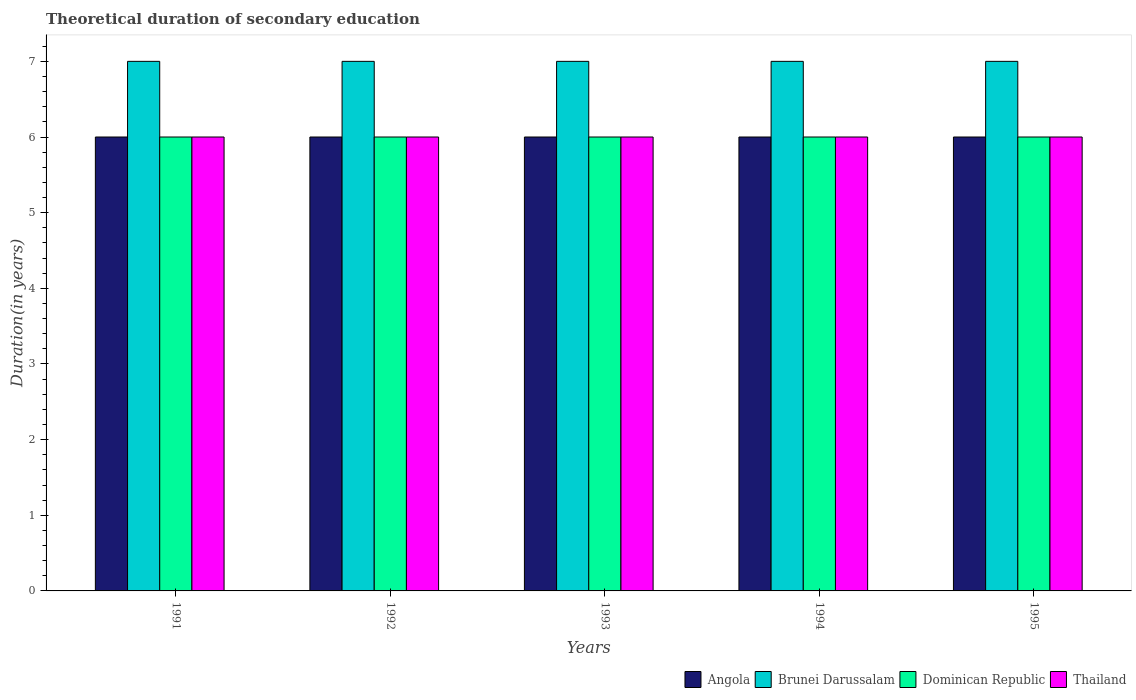How many groups of bars are there?
Provide a succinct answer. 5. Are the number of bars per tick equal to the number of legend labels?
Offer a very short reply. Yes. Are the number of bars on each tick of the X-axis equal?
Keep it short and to the point. Yes. What is the label of the 3rd group of bars from the left?
Give a very brief answer. 1993. In how many cases, is the number of bars for a given year not equal to the number of legend labels?
Your answer should be very brief. 0. What is the total theoretical duration of secondary education in Thailand in 1995?
Your response must be concise. 6. Across all years, what is the minimum total theoretical duration of secondary education in Angola?
Give a very brief answer. 6. In which year was the total theoretical duration of secondary education in Dominican Republic maximum?
Your response must be concise. 1991. What is the total total theoretical duration of secondary education in Angola in the graph?
Your answer should be very brief. 30. What is the difference between the total theoretical duration of secondary education in Brunei Darussalam in 1991 and that in 1994?
Give a very brief answer. 0. What is the difference between the total theoretical duration of secondary education in Brunei Darussalam in 1993 and the total theoretical duration of secondary education in Angola in 1991?
Keep it short and to the point. 1. What is the average total theoretical duration of secondary education in Brunei Darussalam per year?
Provide a short and direct response. 7. In the year 1991, what is the difference between the total theoretical duration of secondary education in Angola and total theoretical duration of secondary education in Brunei Darussalam?
Offer a terse response. -1. In how many years, is the total theoretical duration of secondary education in Angola greater than 5 years?
Your answer should be very brief. 5. Is the difference between the total theoretical duration of secondary education in Angola in 1991 and 1995 greater than the difference between the total theoretical duration of secondary education in Brunei Darussalam in 1991 and 1995?
Offer a very short reply. No. What is the difference between the highest and the second highest total theoretical duration of secondary education in Angola?
Provide a short and direct response. 0. What is the difference between the highest and the lowest total theoretical duration of secondary education in Thailand?
Your answer should be compact. 0. In how many years, is the total theoretical duration of secondary education in Brunei Darussalam greater than the average total theoretical duration of secondary education in Brunei Darussalam taken over all years?
Your answer should be compact. 0. Is it the case that in every year, the sum of the total theoretical duration of secondary education in Thailand and total theoretical duration of secondary education in Dominican Republic is greater than the sum of total theoretical duration of secondary education in Brunei Darussalam and total theoretical duration of secondary education in Angola?
Ensure brevity in your answer.  No. What does the 2nd bar from the left in 1991 represents?
Provide a short and direct response. Brunei Darussalam. What does the 4th bar from the right in 1991 represents?
Offer a very short reply. Angola. How many years are there in the graph?
Offer a very short reply. 5. What is the difference between two consecutive major ticks on the Y-axis?
Your response must be concise. 1. How are the legend labels stacked?
Ensure brevity in your answer.  Horizontal. What is the title of the graph?
Offer a terse response. Theoretical duration of secondary education. Does "Bahamas" appear as one of the legend labels in the graph?
Make the answer very short. No. What is the label or title of the X-axis?
Provide a short and direct response. Years. What is the label or title of the Y-axis?
Offer a terse response. Duration(in years). What is the Duration(in years) of Dominican Republic in 1991?
Ensure brevity in your answer.  6. What is the Duration(in years) in Thailand in 1991?
Make the answer very short. 6. What is the Duration(in years) of Brunei Darussalam in 1992?
Keep it short and to the point. 7. What is the Duration(in years) in Thailand in 1992?
Offer a very short reply. 6. What is the Duration(in years) of Brunei Darussalam in 1993?
Ensure brevity in your answer.  7. What is the Duration(in years) of Dominican Republic in 1993?
Your answer should be very brief. 6. What is the Duration(in years) of Thailand in 1993?
Provide a succinct answer. 6. What is the Duration(in years) in Brunei Darussalam in 1994?
Your answer should be compact. 7. What is the Duration(in years) of Dominican Republic in 1994?
Your response must be concise. 6. What is the Duration(in years) of Thailand in 1994?
Provide a short and direct response. 6. Across all years, what is the maximum Duration(in years) in Brunei Darussalam?
Keep it short and to the point. 7. Across all years, what is the minimum Duration(in years) of Angola?
Provide a short and direct response. 6. Across all years, what is the minimum Duration(in years) of Thailand?
Give a very brief answer. 6. What is the total Duration(in years) in Angola in the graph?
Offer a very short reply. 30. What is the total Duration(in years) of Brunei Darussalam in the graph?
Your answer should be very brief. 35. What is the difference between the Duration(in years) in Angola in 1991 and that in 1992?
Make the answer very short. 0. What is the difference between the Duration(in years) of Angola in 1991 and that in 1993?
Offer a very short reply. 0. What is the difference between the Duration(in years) of Brunei Darussalam in 1991 and that in 1993?
Offer a very short reply. 0. What is the difference between the Duration(in years) of Angola in 1991 and that in 1994?
Your answer should be very brief. 0. What is the difference between the Duration(in years) of Dominican Republic in 1991 and that in 1994?
Provide a short and direct response. 0. What is the difference between the Duration(in years) in Thailand in 1991 and that in 1994?
Your response must be concise. 0. What is the difference between the Duration(in years) of Angola in 1991 and that in 1995?
Make the answer very short. 0. What is the difference between the Duration(in years) in Brunei Darussalam in 1991 and that in 1995?
Give a very brief answer. 0. What is the difference between the Duration(in years) in Dominican Republic in 1991 and that in 1995?
Offer a terse response. 0. What is the difference between the Duration(in years) of Angola in 1992 and that in 1993?
Provide a short and direct response. 0. What is the difference between the Duration(in years) in Brunei Darussalam in 1992 and that in 1993?
Ensure brevity in your answer.  0. What is the difference between the Duration(in years) of Brunei Darussalam in 1992 and that in 1994?
Offer a terse response. 0. What is the difference between the Duration(in years) of Dominican Republic in 1992 and that in 1994?
Offer a very short reply. 0. What is the difference between the Duration(in years) of Thailand in 1992 and that in 1994?
Your response must be concise. 0. What is the difference between the Duration(in years) in Angola in 1993 and that in 1994?
Offer a terse response. 0. What is the difference between the Duration(in years) in Dominican Republic in 1993 and that in 1994?
Give a very brief answer. 0. What is the difference between the Duration(in years) of Thailand in 1993 and that in 1994?
Provide a succinct answer. 0. What is the difference between the Duration(in years) in Angola in 1993 and that in 1995?
Offer a very short reply. 0. What is the difference between the Duration(in years) in Brunei Darussalam in 1993 and that in 1995?
Your response must be concise. 0. What is the difference between the Duration(in years) in Dominican Republic in 1993 and that in 1995?
Your answer should be compact. 0. What is the difference between the Duration(in years) in Thailand in 1993 and that in 1995?
Your answer should be compact. 0. What is the difference between the Duration(in years) in Angola in 1994 and that in 1995?
Give a very brief answer. 0. What is the difference between the Duration(in years) in Brunei Darussalam in 1994 and that in 1995?
Give a very brief answer. 0. What is the difference between the Duration(in years) in Angola in 1991 and the Duration(in years) in Brunei Darussalam in 1992?
Ensure brevity in your answer.  -1. What is the difference between the Duration(in years) in Brunei Darussalam in 1991 and the Duration(in years) in Dominican Republic in 1992?
Your response must be concise. 1. What is the difference between the Duration(in years) in Dominican Republic in 1991 and the Duration(in years) in Thailand in 1992?
Your answer should be very brief. 0. What is the difference between the Duration(in years) in Angola in 1991 and the Duration(in years) in Brunei Darussalam in 1993?
Your answer should be compact. -1. What is the difference between the Duration(in years) in Angola in 1991 and the Duration(in years) in Thailand in 1994?
Your answer should be very brief. 0. What is the difference between the Duration(in years) in Brunei Darussalam in 1991 and the Duration(in years) in Thailand in 1994?
Your answer should be very brief. 1. What is the difference between the Duration(in years) in Dominican Republic in 1991 and the Duration(in years) in Thailand in 1994?
Provide a short and direct response. 0. What is the difference between the Duration(in years) of Angola in 1991 and the Duration(in years) of Brunei Darussalam in 1995?
Keep it short and to the point. -1. What is the difference between the Duration(in years) in Brunei Darussalam in 1991 and the Duration(in years) in Dominican Republic in 1995?
Provide a short and direct response. 1. What is the difference between the Duration(in years) in Brunei Darussalam in 1991 and the Duration(in years) in Thailand in 1995?
Give a very brief answer. 1. What is the difference between the Duration(in years) in Angola in 1992 and the Duration(in years) in Dominican Republic in 1993?
Ensure brevity in your answer.  0. What is the difference between the Duration(in years) in Angola in 1992 and the Duration(in years) in Thailand in 1993?
Ensure brevity in your answer.  0. What is the difference between the Duration(in years) of Brunei Darussalam in 1992 and the Duration(in years) of Dominican Republic in 1993?
Provide a short and direct response. 1. What is the difference between the Duration(in years) in Angola in 1992 and the Duration(in years) in Dominican Republic in 1994?
Your answer should be very brief. 0. What is the difference between the Duration(in years) of Brunei Darussalam in 1992 and the Duration(in years) of Dominican Republic in 1994?
Offer a terse response. 1. What is the difference between the Duration(in years) of Brunei Darussalam in 1992 and the Duration(in years) of Thailand in 1994?
Give a very brief answer. 1. What is the difference between the Duration(in years) of Angola in 1992 and the Duration(in years) of Brunei Darussalam in 1995?
Give a very brief answer. -1. What is the difference between the Duration(in years) in Brunei Darussalam in 1992 and the Duration(in years) in Dominican Republic in 1995?
Make the answer very short. 1. What is the difference between the Duration(in years) in Dominican Republic in 1992 and the Duration(in years) in Thailand in 1995?
Make the answer very short. 0. What is the difference between the Duration(in years) in Angola in 1993 and the Duration(in years) in Brunei Darussalam in 1994?
Provide a short and direct response. -1. What is the difference between the Duration(in years) in Angola in 1993 and the Duration(in years) in Dominican Republic in 1994?
Provide a succinct answer. 0. What is the difference between the Duration(in years) of Angola in 1993 and the Duration(in years) of Thailand in 1994?
Ensure brevity in your answer.  0. What is the difference between the Duration(in years) in Dominican Republic in 1993 and the Duration(in years) in Thailand in 1994?
Make the answer very short. 0. What is the difference between the Duration(in years) of Angola in 1993 and the Duration(in years) of Brunei Darussalam in 1995?
Provide a succinct answer. -1. What is the difference between the Duration(in years) in Angola in 1993 and the Duration(in years) in Dominican Republic in 1995?
Your response must be concise. 0. What is the difference between the Duration(in years) of Brunei Darussalam in 1993 and the Duration(in years) of Thailand in 1995?
Your answer should be compact. 1. What is the difference between the Duration(in years) in Dominican Republic in 1993 and the Duration(in years) in Thailand in 1995?
Your response must be concise. 0. What is the difference between the Duration(in years) in Angola in 1994 and the Duration(in years) in Brunei Darussalam in 1995?
Your answer should be very brief. -1. What is the difference between the Duration(in years) in Angola in 1994 and the Duration(in years) in Dominican Republic in 1995?
Make the answer very short. 0. What is the difference between the Duration(in years) in Angola in 1994 and the Duration(in years) in Thailand in 1995?
Keep it short and to the point. 0. What is the difference between the Duration(in years) in Brunei Darussalam in 1994 and the Duration(in years) in Dominican Republic in 1995?
Ensure brevity in your answer.  1. What is the difference between the Duration(in years) of Brunei Darussalam in 1994 and the Duration(in years) of Thailand in 1995?
Provide a short and direct response. 1. What is the difference between the Duration(in years) of Dominican Republic in 1994 and the Duration(in years) of Thailand in 1995?
Make the answer very short. 0. What is the average Duration(in years) in Angola per year?
Your response must be concise. 6. What is the average Duration(in years) in Dominican Republic per year?
Give a very brief answer. 6. What is the average Duration(in years) in Thailand per year?
Keep it short and to the point. 6. In the year 1991, what is the difference between the Duration(in years) of Angola and Duration(in years) of Brunei Darussalam?
Keep it short and to the point. -1. In the year 1991, what is the difference between the Duration(in years) of Brunei Darussalam and Duration(in years) of Thailand?
Provide a succinct answer. 1. In the year 1991, what is the difference between the Duration(in years) in Dominican Republic and Duration(in years) in Thailand?
Give a very brief answer. 0. In the year 1992, what is the difference between the Duration(in years) of Angola and Duration(in years) of Dominican Republic?
Your response must be concise. 0. In the year 1992, what is the difference between the Duration(in years) in Angola and Duration(in years) in Thailand?
Your response must be concise. 0. In the year 1992, what is the difference between the Duration(in years) in Brunei Darussalam and Duration(in years) in Dominican Republic?
Offer a very short reply. 1. In the year 1993, what is the difference between the Duration(in years) of Angola and Duration(in years) of Brunei Darussalam?
Offer a very short reply. -1. In the year 1994, what is the difference between the Duration(in years) of Angola and Duration(in years) of Thailand?
Your answer should be very brief. 0. In the year 1994, what is the difference between the Duration(in years) in Brunei Darussalam and Duration(in years) in Dominican Republic?
Give a very brief answer. 1. In the year 1994, what is the difference between the Duration(in years) in Brunei Darussalam and Duration(in years) in Thailand?
Your response must be concise. 1. In the year 1994, what is the difference between the Duration(in years) in Dominican Republic and Duration(in years) in Thailand?
Ensure brevity in your answer.  0. In the year 1995, what is the difference between the Duration(in years) in Angola and Duration(in years) in Dominican Republic?
Provide a succinct answer. 0. In the year 1995, what is the difference between the Duration(in years) in Angola and Duration(in years) in Thailand?
Provide a succinct answer. 0. What is the ratio of the Duration(in years) of Brunei Darussalam in 1991 to that in 1992?
Keep it short and to the point. 1. What is the ratio of the Duration(in years) in Dominican Republic in 1991 to that in 1992?
Offer a terse response. 1. What is the ratio of the Duration(in years) of Angola in 1991 to that in 1993?
Offer a terse response. 1. What is the ratio of the Duration(in years) of Dominican Republic in 1991 to that in 1993?
Ensure brevity in your answer.  1. What is the ratio of the Duration(in years) in Angola in 1991 to that in 1994?
Your answer should be very brief. 1. What is the ratio of the Duration(in years) in Dominican Republic in 1991 to that in 1994?
Your answer should be compact. 1. What is the ratio of the Duration(in years) of Brunei Darussalam in 1991 to that in 1995?
Provide a short and direct response. 1. What is the ratio of the Duration(in years) of Thailand in 1991 to that in 1995?
Ensure brevity in your answer.  1. What is the ratio of the Duration(in years) in Brunei Darussalam in 1992 to that in 1993?
Your response must be concise. 1. What is the ratio of the Duration(in years) of Dominican Republic in 1992 to that in 1993?
Offer a terse response. 1. What is the ratio of the Duration(in years) in Angola in 1993 to that in 1994?
Your answer should be compact. 1. What is the ratio of the Duration(in years) of Thailand in 1993 to that in 1994?
Offer a terse response. 1. What is the ratio of the Duration(in years) in Brunei Darussalam in 1993 to that in 1995?
Your response must be concise. 1. What is the ratio of the Duration(in years) of Brunei Darussalam in 1994 to that in 1995?
Offer a terse response. 1. What is the ratio of the Duration(in years) of Thailand in 1994 to that in 1995?
Provide a short and direct response. 1. What is the difference between the highest and the lowest Duration(in years) in Angola?
Give a very brief answer. 0. 